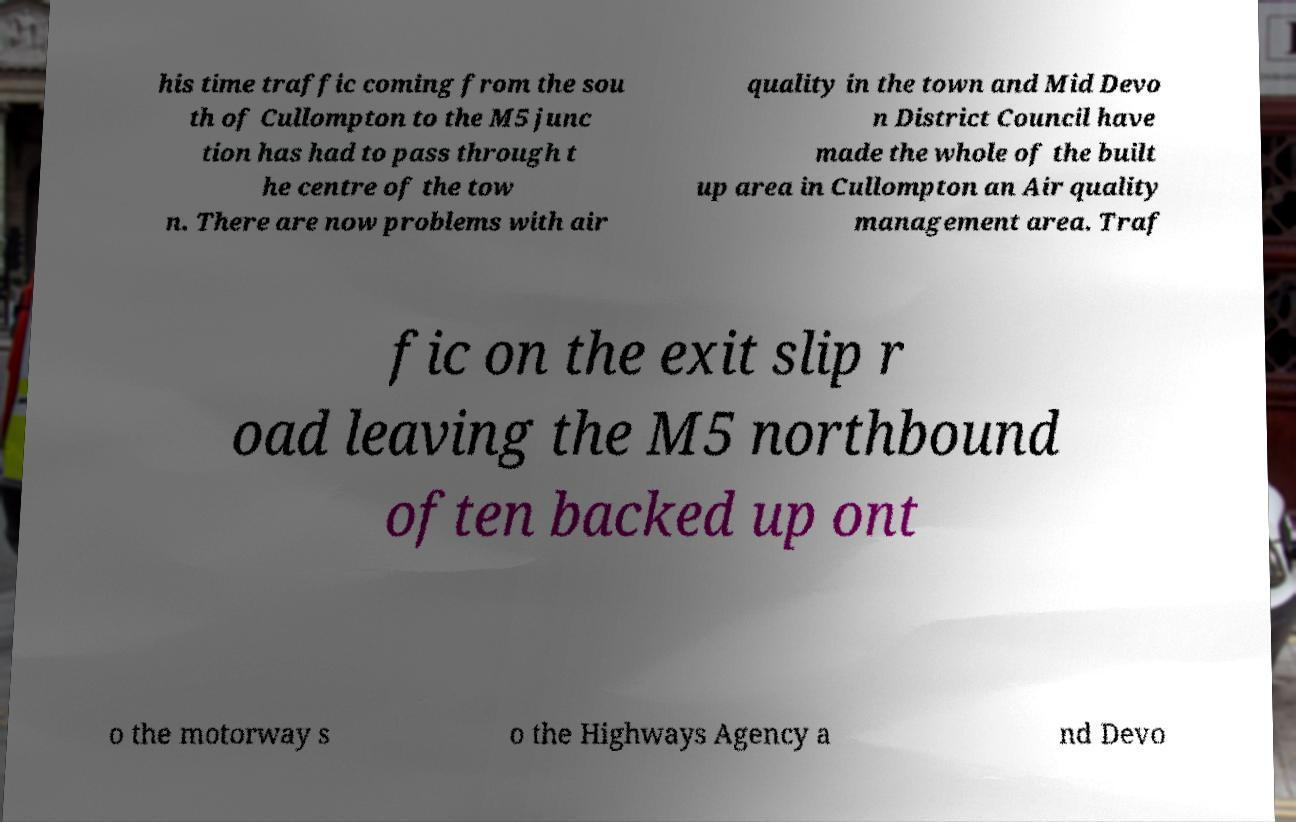Please read and relay the text visible in this image. What does it say? his time traffic coming from the sou th of Cullompton to the M5 junc tion has had to pass through t he centre of the tow n. There are now problems with air quality in the town and Mid Devo n District Council have made the whole of the built up area in Cullompton an Air quality management area. Traf fic on the exit slip r oad leaving the M5 northbound often backed up ont o the motorway s o the Highways Agency a nd Devo 